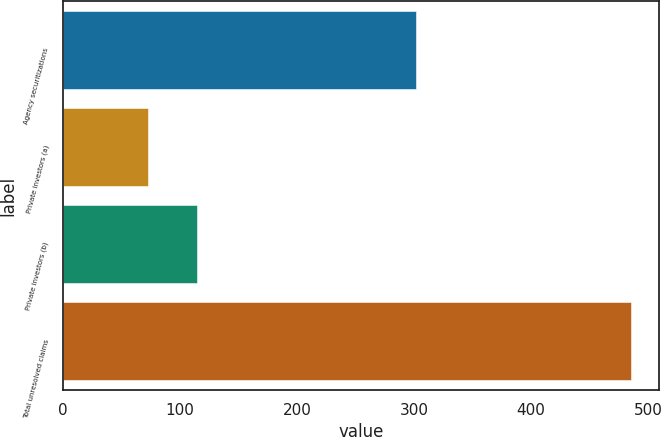Convert chart. <chart><loc_0><loc_0><loc_500><loc_500><bar_chart><fcel>Agency securitizations<fcel>Private investors (a)<fcel>Private investors (b)<fcel>Total unresolved claims<nl><fcel>302<fcel>73<fcel>114.2<fcel>485<nl></chart> 